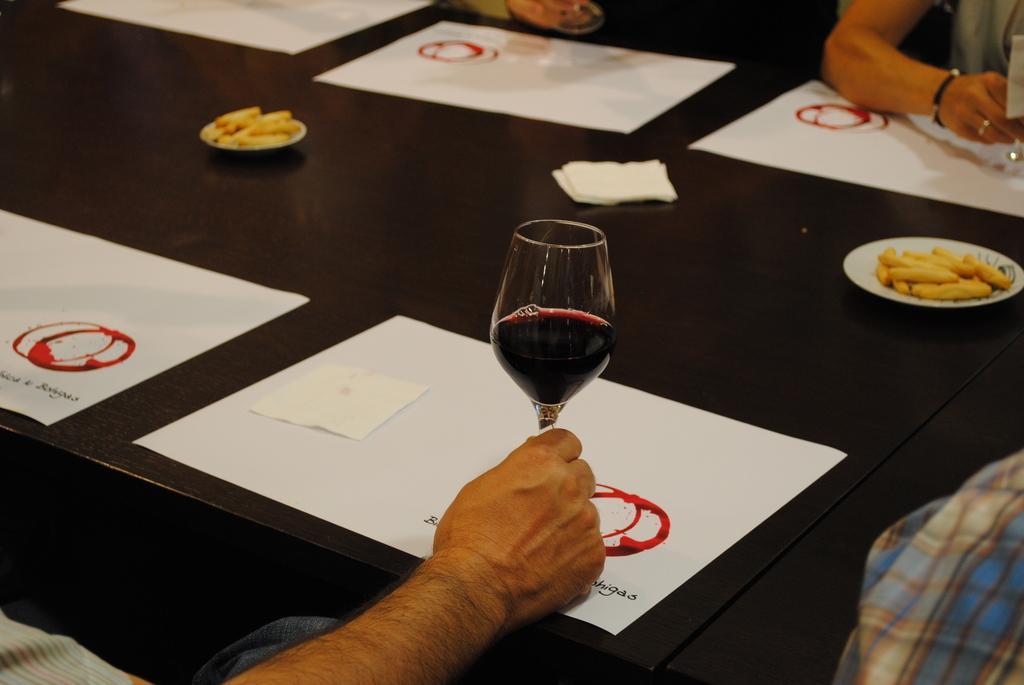Describe this image in one or two sentences. As we can see in the image, there is a table. On table there are paper, plates and a glass 